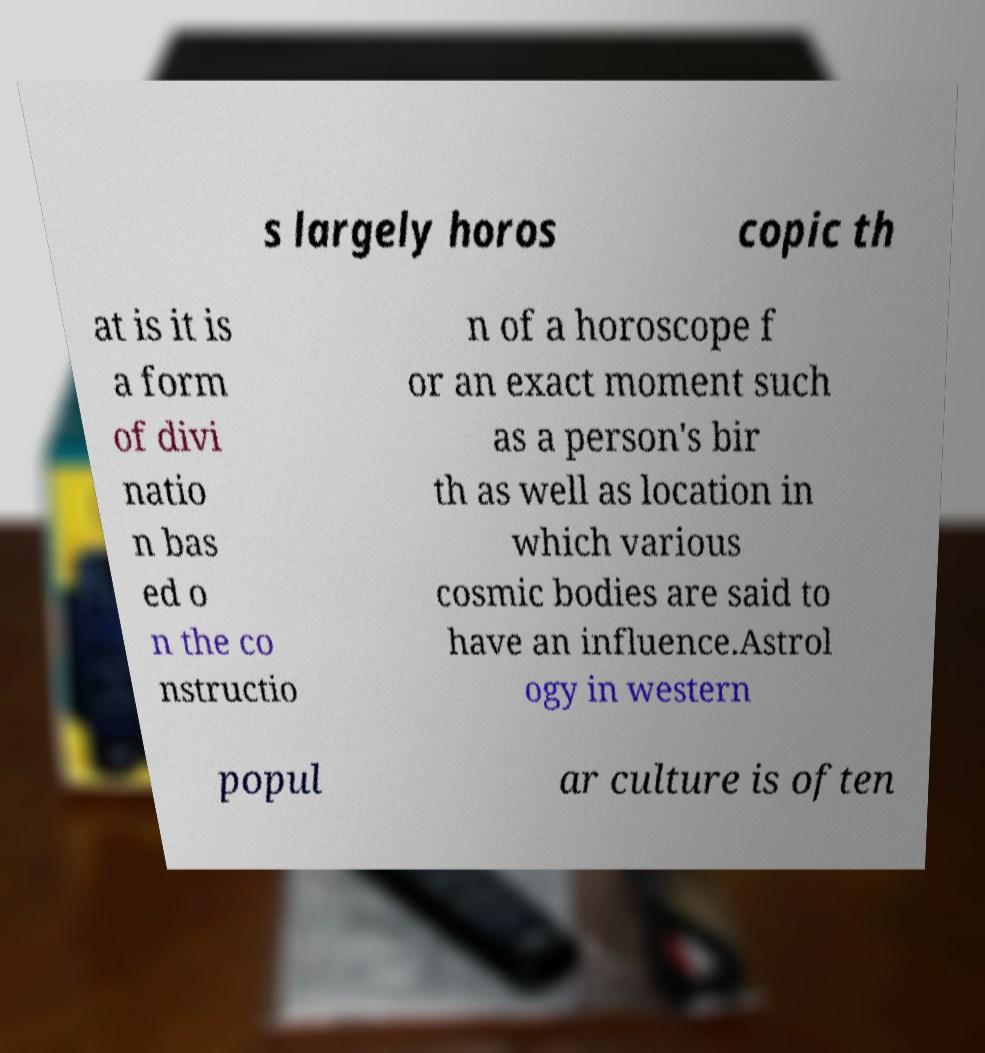Could you extract and type out the text from this image? s largely horos copic th at is it is a form of divi natio n bas ed o n the co nstructio n of a horoscope f or an exact moment such as a person's bir th as well as location in which various cosmic bodies are said to have an influence.Astrol ogy in western popul ar culture is often 